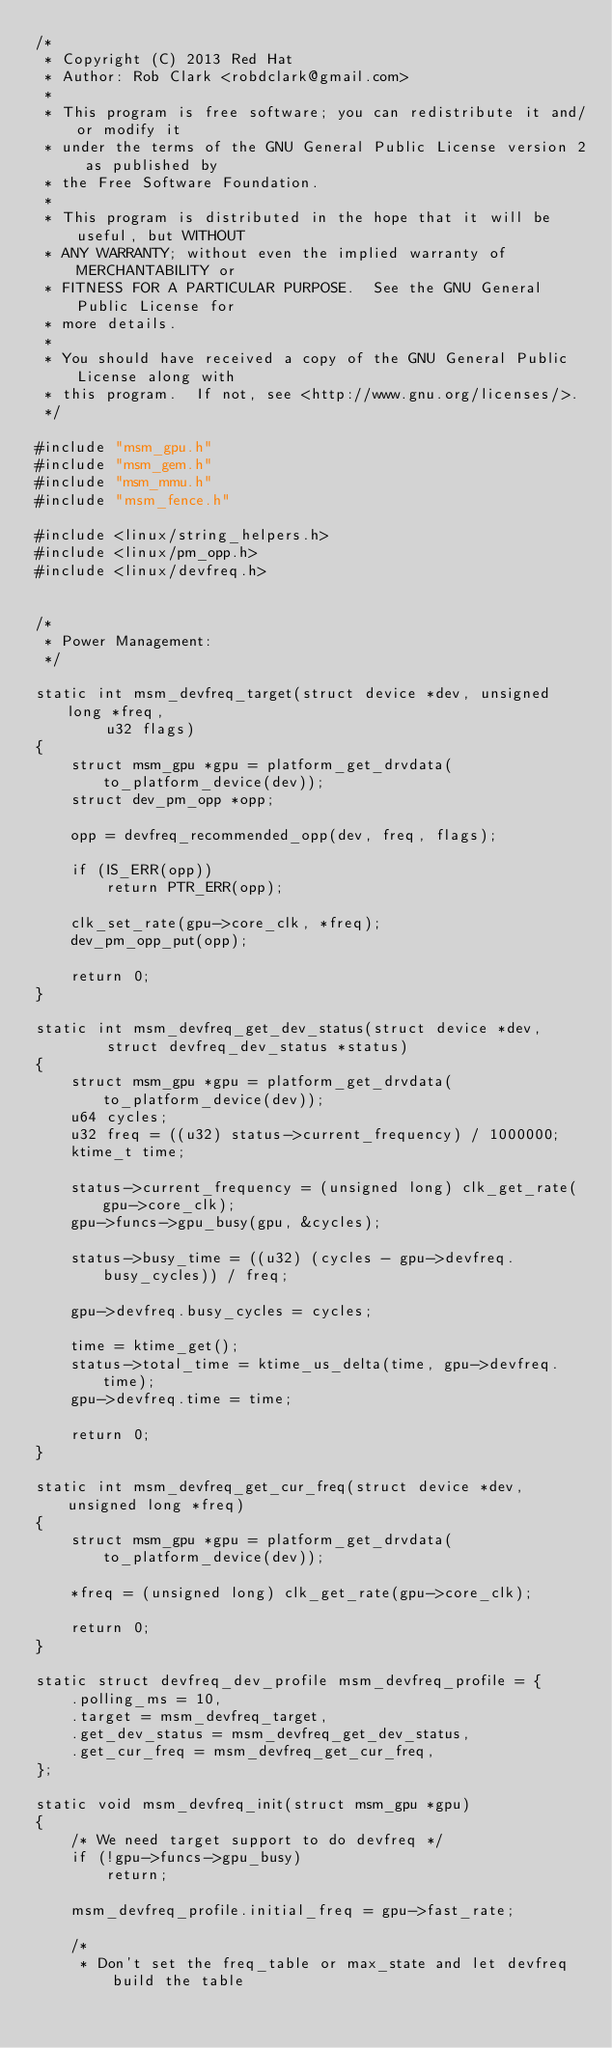<code> <loc_0><loc_0><loc_500><loc_500><_C_>/*
 * Copyright (C) 2013 Red Hat
 * Author: Rob Clark <robdclark@gmail.com>
 *
 * This program is free software; you can redistribute it and/or modify it
 * under the terms of the GNU General Public License version 2 as published by
 * the Free Software Foundation.
 *
 * This program is distributed in the hope that it will be useful, but WITHOUT
 * ANY WARRANTY; without even the implied warranty of MERCHANTABILITY or
 * FITNESS FOR A PARTICULAR PURPOSE.  See the GNU General Public License for
 * more details.
 *
 * You should have received a copy of the GNU General Public License along with
 * this program.  If not, see <http://www.gnu.org/licenses/>.
 */

#include "msm_gpu.h"
#include "msm_gem.h"
#include "msm_mmu.h"
#include "msm_fence.h"

#include <linux/string_helpers.h>
#include <linux/pm_opp.h>
#include <linux/devfreq.h>


/*
 * Power Management:
 */

static int msm_devfreq_target(struct device *dev, unsigned long *freq,
		u32 flags)
{
	struct msm_gpu *gpu = platform_get_drvdata(to_platform_device(dev));
	struct dev_pm_opp *opp;

	opp = devfreq_recommended_opp(dev, freq, flags);

	if (IS_ERR(opp))
		return PTR_ERR(opp);

	clk_set_rate(gpu->core_clk, *freq);
	dev_pm_opp_put(opp);

	return 0;
}

static int msm_devfreq_get_dev_status(struct device *dev,
		struct devfreq_dev_status *status)
{
	struct msm_gpu *gpu = platform_get_drvdata(to_platform_device(dev));
	u64 cycles;
	u32 freq = ((u32) status->current_frequency) / 1000000;
	ktime_t time;

	status->current_frequency = (unsigned long) clk_get_rate(gpu->core_clk);
	gpu->funcs->gpu_busy(gpu, &cycles);

	status->busy_time = ((u32) (cycles - gpu->devfreq.busy_cycles)) / freq;

	gpu->devfreq.busy_cycles = cycles;

	time = ktime_get();
	status->total_time = ktime_us_delta(time, gpu->devfreq.time);
	gpu->devfreq.time = time;

	return 0;
}

static int msm_devfreq_get_cur_freq(struct device *dev, unsigned long *freq)
{
	struct msm_gpu *gpu = platform_get_drvdata(to_platform_device(dev));

	*freq = (unsigned long) clk_get_rate(gpu->core_clk);

	return 0;
}

static struct devfreq_dev_profile msm_devfreq_profile = {
	.polling_ms = 10,
	.target = msm_devfreq_target,
	.get_dev_status = msm_devfreq_get_dev_status,
	.get_cur_freq = msm_devfreq_get_cur_freq,
};

static void msm_devfreq_init(struct msm_gpu *gpu)
{
	/* We need target support to do devfreq */
	if (!gpu->funcs->gpu_busy)
		return;

	msm_devfreq_profile.initial_freq = gpu->fast_rate;

	/*
	 * Don't set the freq_table or max_state and let devfreq build the table</code> 